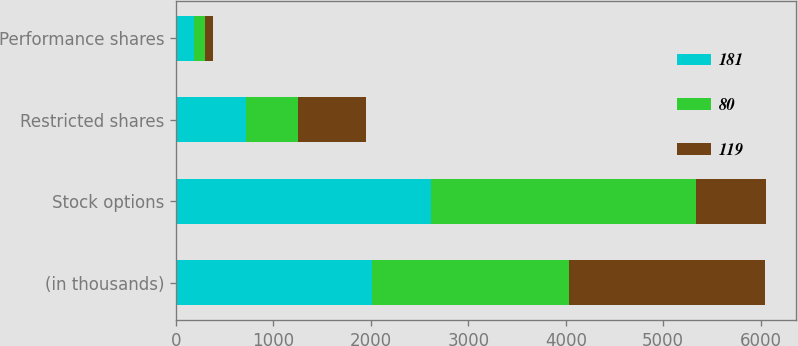<chart> <loc_0><loc_0><loc_500><loc_500><stacked_bar_chart><ecel><fcel>(in thousands)<fcel>Stock options<fcel>Restricted shares<fcel>Performance shares<nl><fcel>181<fcel>2015<fcel>2616<fcel>723<fcel>181<nl><fcel>80<fcel>2014<fcel>2720<fcel>525<fcel>119<nl><fcel>119<fcel>2013<fcel>723<fcel>703<fcel>80<nl></chart> 